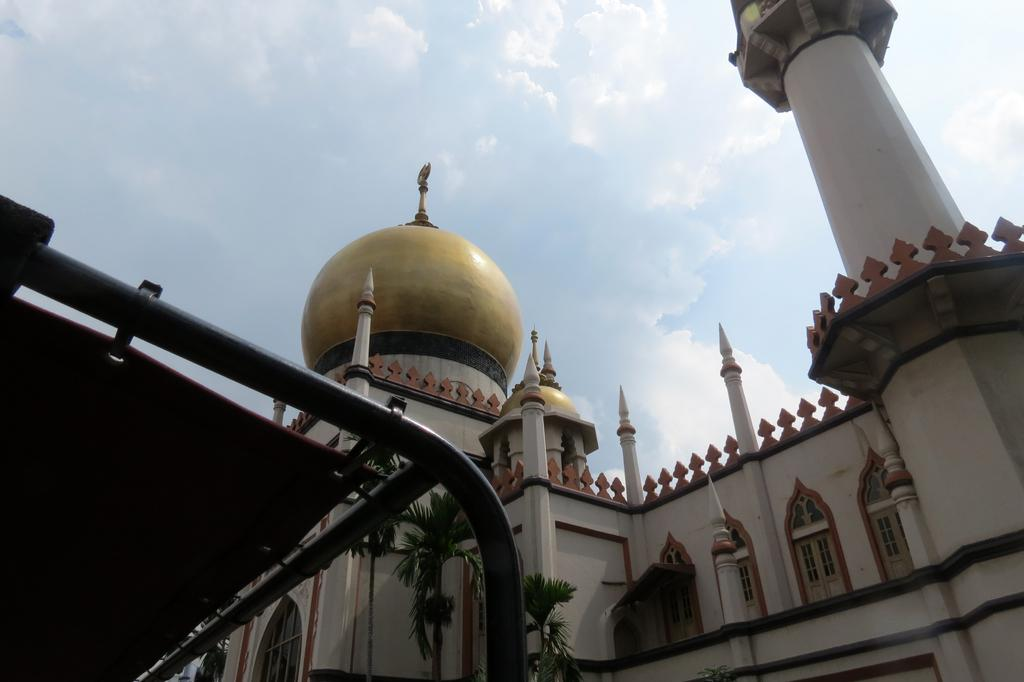What type of structure is present in the image? There is a building in the image. What colors are used on the building? The building has white, black, and gold colors. Are there any openings on the building? Yes, there are windows on the building. What can be seen in the background of the image? There are trees visible in the image. How would you describe the color of the sky in the image? The sky is white and blue in color. How many cats are sitting on the roof of the building in the image? There are no cats present on the roof or anywhere else in the image. 